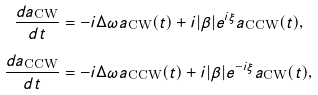Convert formula to latex. <formula><loc_0><loc_0><loc_500><loc_500>\frac { d a _ { \text {CW} } } { d t } & = - i \Delta { \omega } a _ { \text {CW} } ( t ) + i | \beta | e ^ { i \xi } a _ { \text {CCW} } ( t ) , \\ \frac { d a _ { \text {CCW} } } { d t } & = - i \Delta { \omega } a _ { \text {CCW} } ( t ) + i | \beta | e ^ { - i \xi } a _ { \text {CW} } ( t ) ,</formula> 